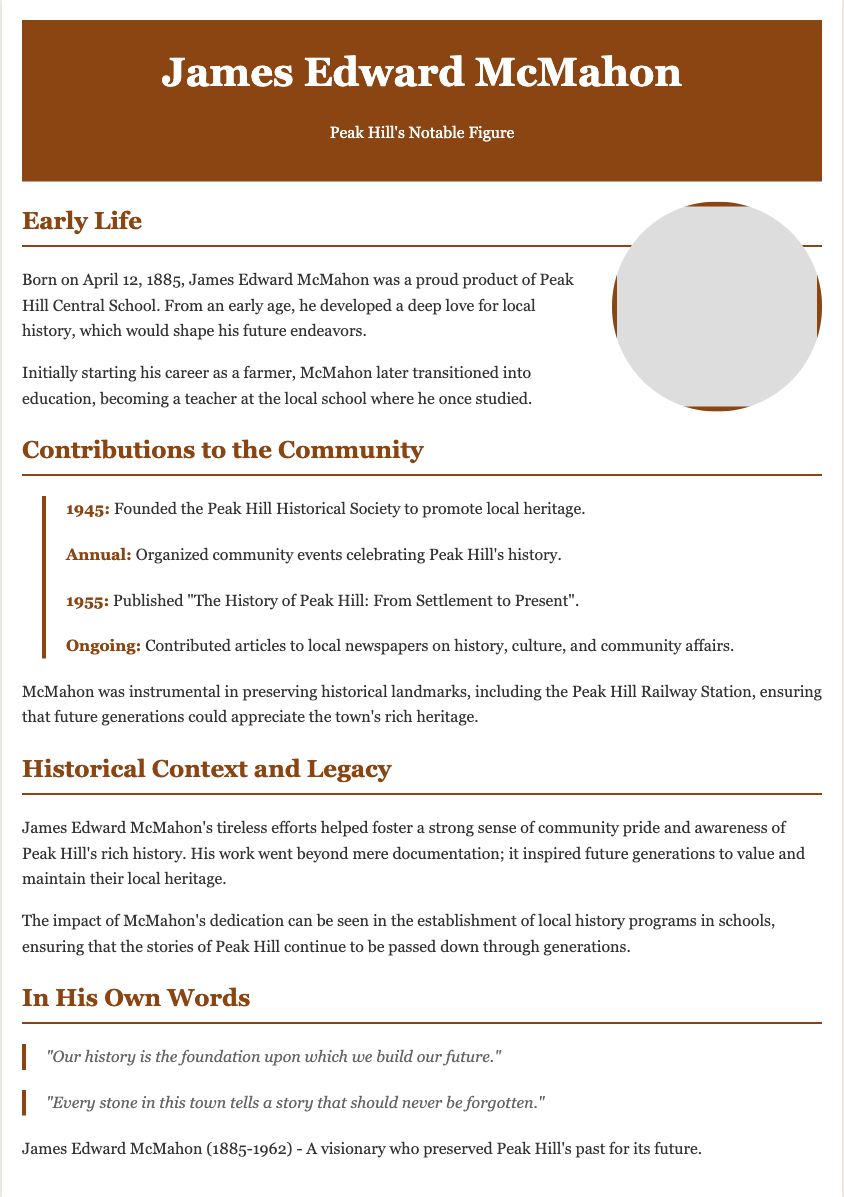What is the birth date of James Edward McMahon? The document states that James Edward McMahon was born on April 12, 1885.
Answer: April 12, 1885 What was the name of the historical society founded by McMahon? The document mentions that he founded the Peak Hill Historical Society in 1945.
Answer: Peak Hill Historical Society In which year did McMahon publish "The History of Peak Hill"? According to the document, McMahon published the book in 1955.
Answer: 1955 What profession did McMahon pursue after being a farmer? The document indicates that he transitioned into education, specifically becoming a teacher.
Answer: Teacher What quote reflects McMahon's view on history? The document provides a quote from McMahon stating, "Our history is the foundation upon which we build our future."
Answer: Our history is the foundation upon which we build our future How did McMahon contribute to the preservation of local heritage? The document notes that he was instrumental in preserving historical landmarks, including the Peak Hill Railway Station.
Answer: Preserving historical landmarks What theme did McMahon's writings often focus on? The document mentions that his articles contributed to discussions on history, culture, and community affairs.
Answer: History, culture, and community affairs What is the main legacy left by McMahon? According to the document, his legacy includes inspiring future generations to value and maintain their local heritage.
Answer: Inspiring future generations to value and maintain local heritage 